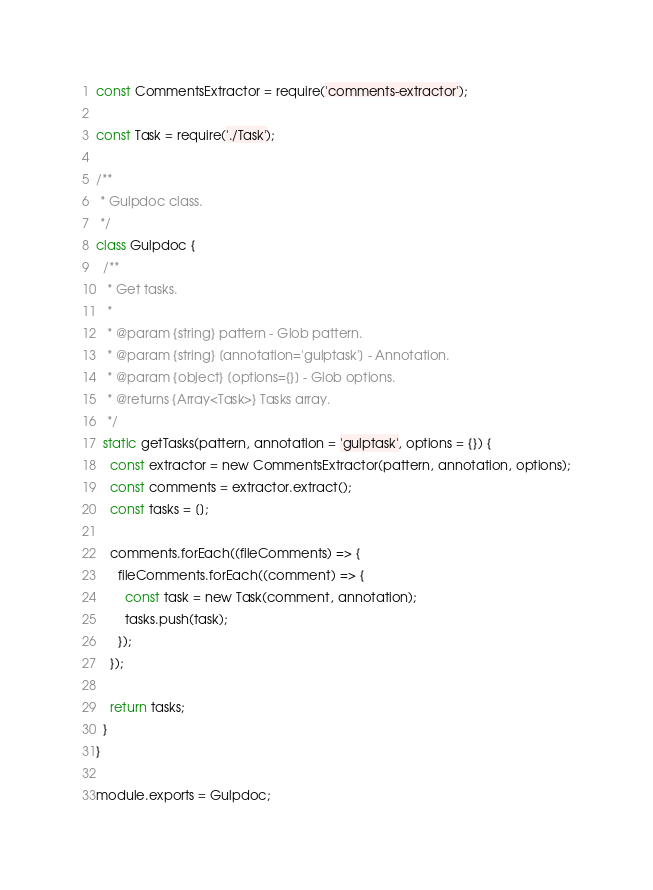<code> <loc_0><loc_0><loc_500><loc_500><_JavaScript_>const CommentsExtractor = require('comments-extractor');

const Task = require('./Task');

/**
 * Gulpdoc class.
 */
class Gulpdoc {
  /**
   * Get tasks.
   *
   * @param {string} pattern - Glob pattern.
   * @param {string} [annotation='gulptask'] - Annotation.
   * @param {object} [options={}] - Glob options.
   * @returns {Array<Task>} Tasks array.
   */
  static getTasks(pattern, annotation = 'gulptask', options = {}) {
    const extractor = new CommentsExtractor(pattern, annotation, options);
    const comments = extractor.extract();
    const tasks = [];

    comments.forEach((fileComments) => {
      fileComments.forEach((comment) => {
        const task = new Task(comment, annotation);
        tasks.push(task);
      });
    });

    return tasks;
  }
}

module.exports = Gulpdoc;
</code> 